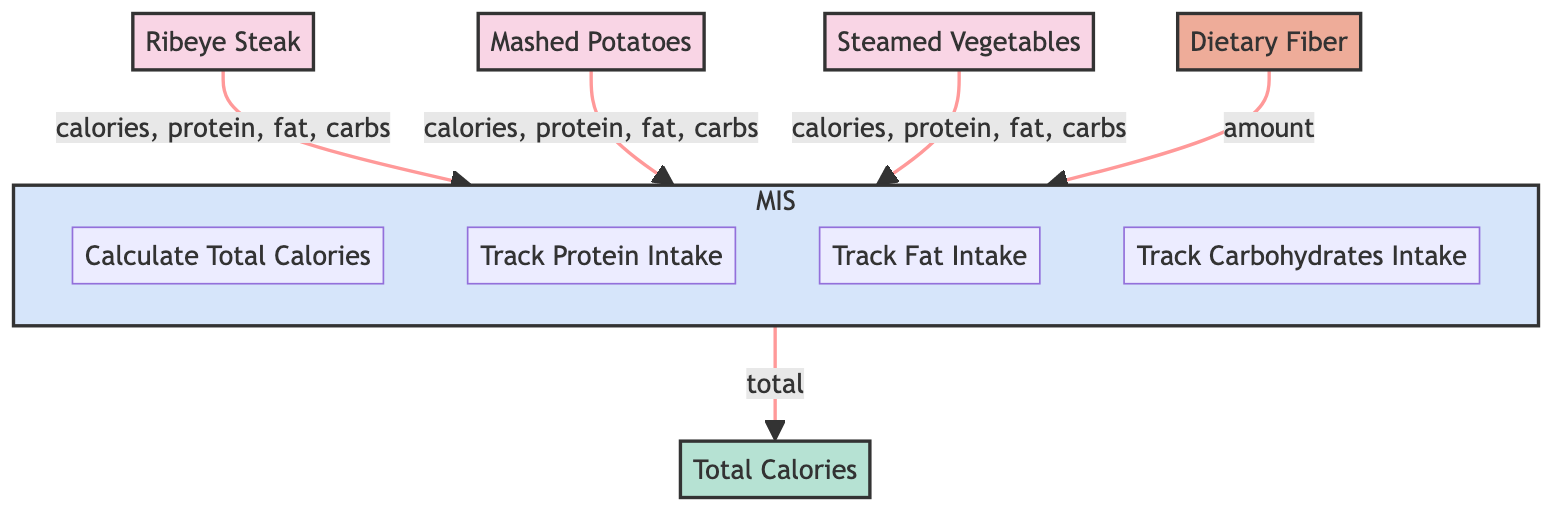How many food items are in the diagram? The diagram lists three food items: Ribeye Steak, Mashed Potatoes, and Steamed Vegetables.
Answer: 3 What is the total calorie count from the Ribeye Steak? The Ribeye Steak contributes 600 calories as indicated in the diagram.
Answer: 600 What nutritional component is associated with Steamed Vegetables? The Steamed Vegetables have an associated nutritional component of Dietary Fiber, which is mentioned in the diagram.
Answer: Dietary Fiber How many processes are included in the Meal Information System? The Meal Information System has four processes: Calculate Total Calories, Track Protein Intake, Track Fat Intake, and Track Carbohydrates Intake.
Answer: 4 What is the total calories calculated by the Meal Information System? The Meal Information System outputs a total calorie summary of 850, as indicated in the diagram.
Answer: 850 Which food item has the highest fat content? The Ribeye Steak has the highest fat content at 48g, as stated in the diagram.
Answer: Ribeye Steak What is the data flow from Mashed Potatoes to the Meal Information System? The data flow from Mashed Potatoes includes calories, protein, fat, and carbohydrates.
Answer: calories, protein, fat, carbohydrates How much dietary fiber is provided by the Steamed Vegetables? The Steamed Vegetables provide 5g of dietary fiber, which is specified in the nutritional component.
Answer: 5g Which food item contributes zero carbohydrates? The Ribeye Steak contributes zero carbohydrates, as indicated in the diagram.
Answer: Ribeye Steak 